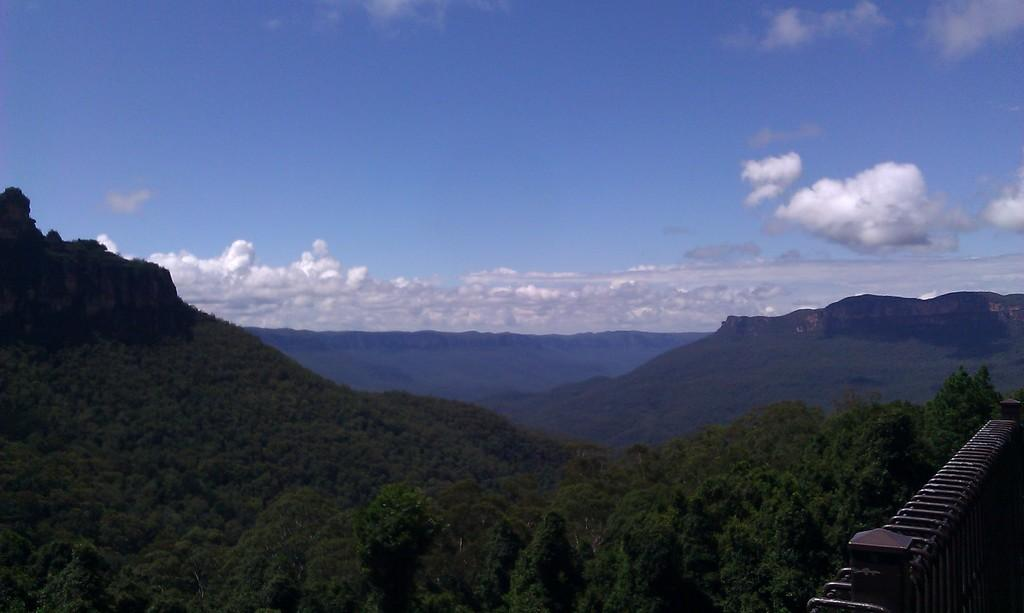What type of natural formation can be seen in the image? There are mountains in the image. What is located on the right side of the image? There is a railing on the right side of the image. What can be seen in the sky at the top of the image? There are clouds in the sky at the top of the image. What type of club is visible in the image? There is no club present in the image. What month is depicted on the calendar in the image? There is no calendar present in the image. 